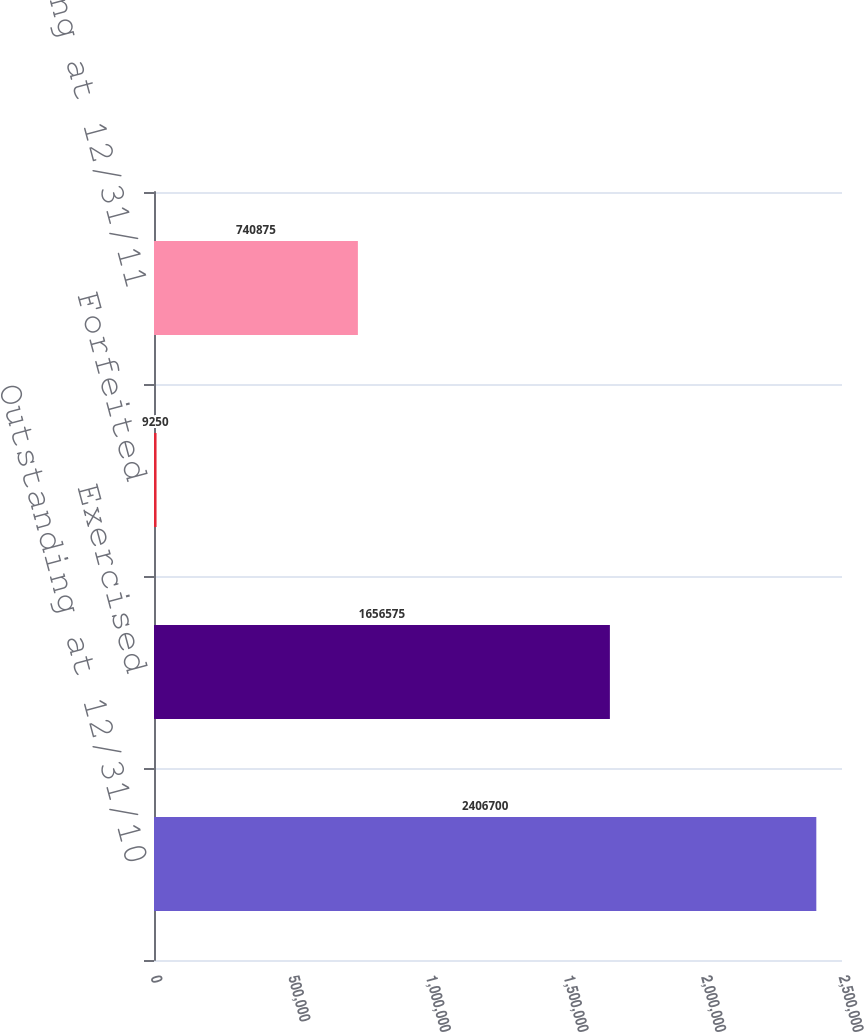Convert chart. <chart><loc_0><loc_0><loc_500><loc_500><bar_chart><fcel>Outstanding at 12/31/10<fcel>Exercised<fcel>Forfeited<fcel>Outstanding at 12/31/11<nl><fcel>2.4067e+06<fcel>1.65658e+06<fcel>9250<fcel>740875<nl></chart> 